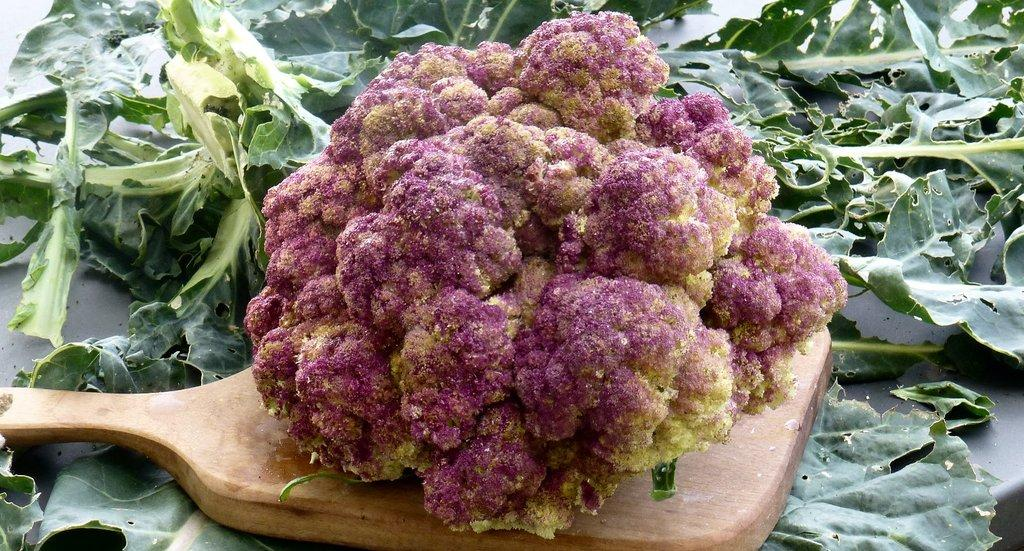What type of vegetation can be seen in the image? There are leaves in the image. What is the main subject in the foreground of the image? There is a cauliflower in the foreground of the image. What is the cauliflower resting on? The cauliflower is on a wooden object. What type of cord is wrapped around the cauliflower in the image? There is no cord present in the image; the cauliflower is resting on a wooden object. 